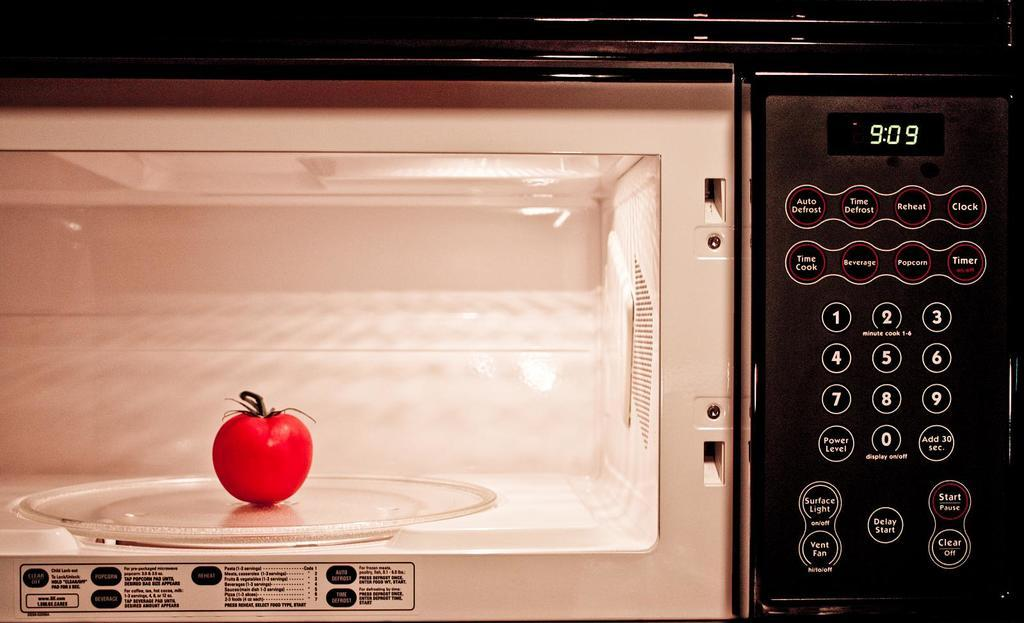<image>
Offer a succinct explanation of the picture presented. A tomato is in a microwave with a display reading 9:09. 